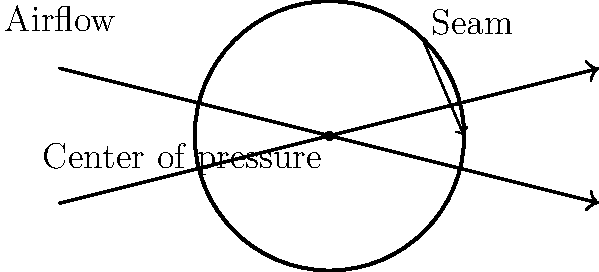In swing bowling, why does the cricket ball deviate from its straight path, and how does the seam position affect this movement? To understand swing bowling in cricket, let's break it down step-by-step:

1. Seam position: The bowler delivers the ball with the seam angled, typically at about 20 degrees to the direction of motion.

2. Airflow: As the ball moves through the air, it creates two types of airflow:
   a) Laminar flow: Smooth airflow on one side of the ball
   b) Turbulent flow: Disturbed airflow on the other side, caused by the angled seam

3. Bernoulli's principle: This principle states that faster-moving fluids (including air) have lower pressure than slower-moving fluids.

4. Pressure difference: The laminar flow moves faster than the turbulent flow, creating a pressure difference across the ball.

5. Magnus effect: This is the primary cause of swing, resulting from the pressure difference. It creates a force perpendicular to the direction of motion.

6. Lateral movement: The Magnus effect causes the ball to move sideways in the air, deviating from its straight path.

7. Direction of swing: 
   - If the seam is angled towards the slip fielders, the ball swings away from the batsman (outswinger)
   - If the seam is angled towards fine leg, the ball swings into the batsman (inswinger)

8. Ball condition: A newer, shinier ball tends to swing more due to a more pronounced difference between laminar and turbulent flow.

9. Weather conditions: Humid conditions can enhance swing by making the air more dense, increasing the pressure difference.

The combination of these factors results in the curved path of a swinging delivery, making it challenging for batsmen to play.
Answer: Pressure difference across the ball due to asymmetric airflow (Magnus effect) 